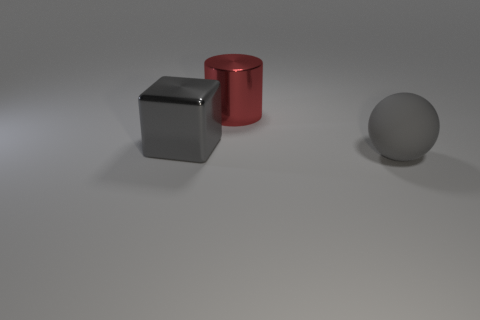How big is the red cylinder?
Provide a short and direct response. Large. What color is the thing right of the big metallic object that is behind the shiny block?
Offer a terse response. Gray. How many large gray objects are both right of the red shiny thing and to the left of the matte sphere?
Your response must be concise. 0. Are there more small purple objects than large blocks?
Offer a very short reply. No. What material is the large gray sphere?
Give a very brief answer. Rubber. There is a big thing in front of the cube; how many objects are behind it?
Provide a succinct answer. 2. Does the rubber ball have the same color as the metallic object that is right of the large gray block?
Your answer should be compact. No. There is a cylinder that is the same size as the gray shiny block; what color is it?
Keep it short and to the point. Red. Is there another large matte object of the same shape as the matte object?
Offer a very short reply. No. Is the number of large cyan metallic balls less than the number of large gray spheres?
Your answer should be very brief. Yes. 